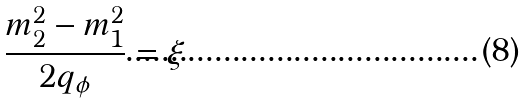Convert formula to latex. <formula><loc_0><loc_0><loc_500><loc_500>\frac { m _ { 2 } ^ { 2 } - m _ { 1 } ^ { 2 } } { 2 q _ { \phi } } = \xi</formula> 